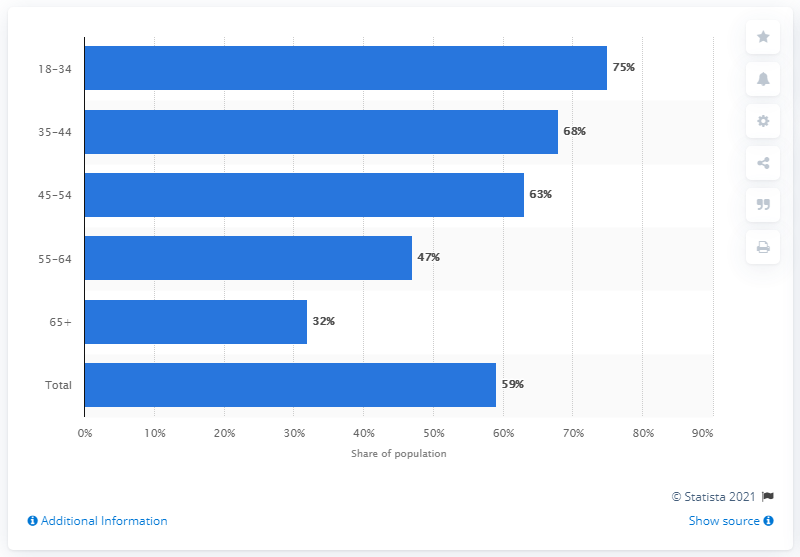Highlight a few significant elements in this photo. A recent survey has revealed that 59% of Canadians use Facebook, indicating a widespread adoption of the social media platform in the country. 